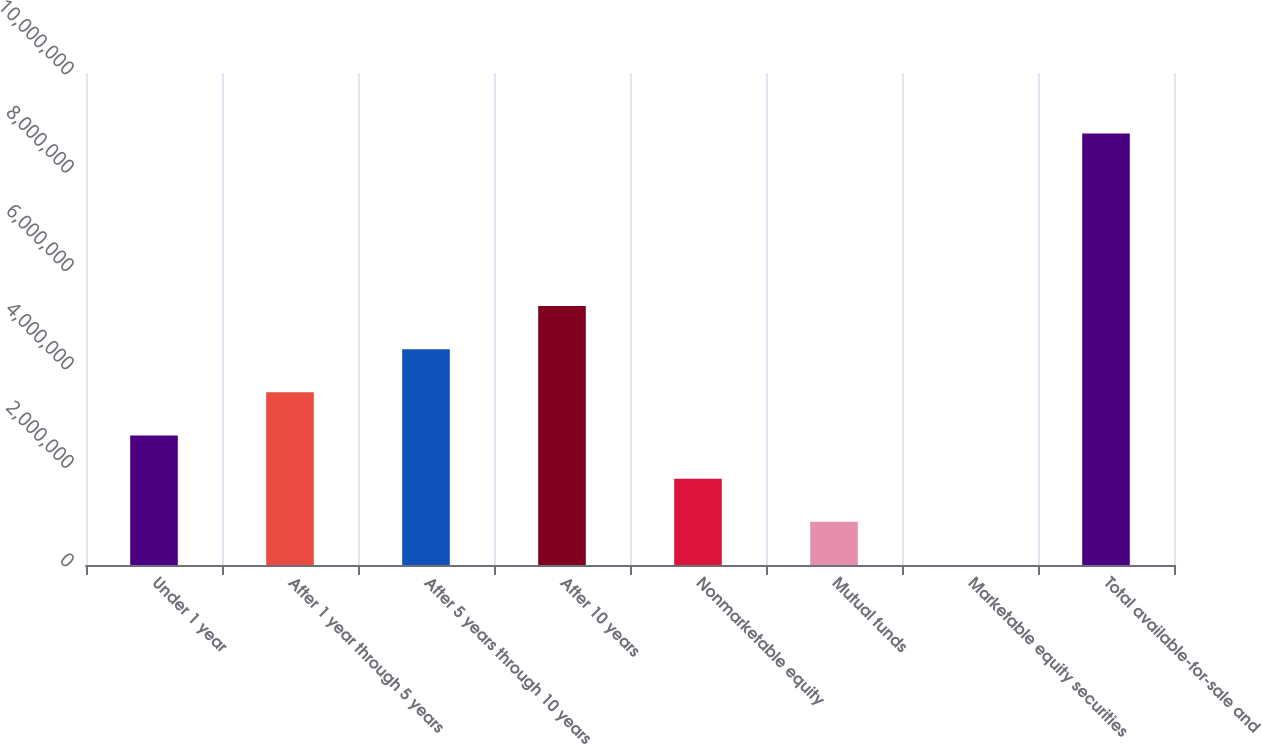Convert chart. <chart><loc_0><loc_0><loc_500><loc_500><bar_chart><fcel>Under 1 year<fcel>After 1 year through 5 years<fcel>After 5 years through 10 years<fcel>After 10 years<fcel>Nonmarketable equity<fcel>Mutual funds<fcel>Marketable equity securities<fcel>Total available-for-sale and<nl><fcel>2.63164e+06<fcel>3.50868e+06<fcel>4.38572e+06<fcel>5.26276e+06<fcel>1.7546e+06<fcel>877565<fcel>525<fcel>8.77092e+06<nl></chart> 